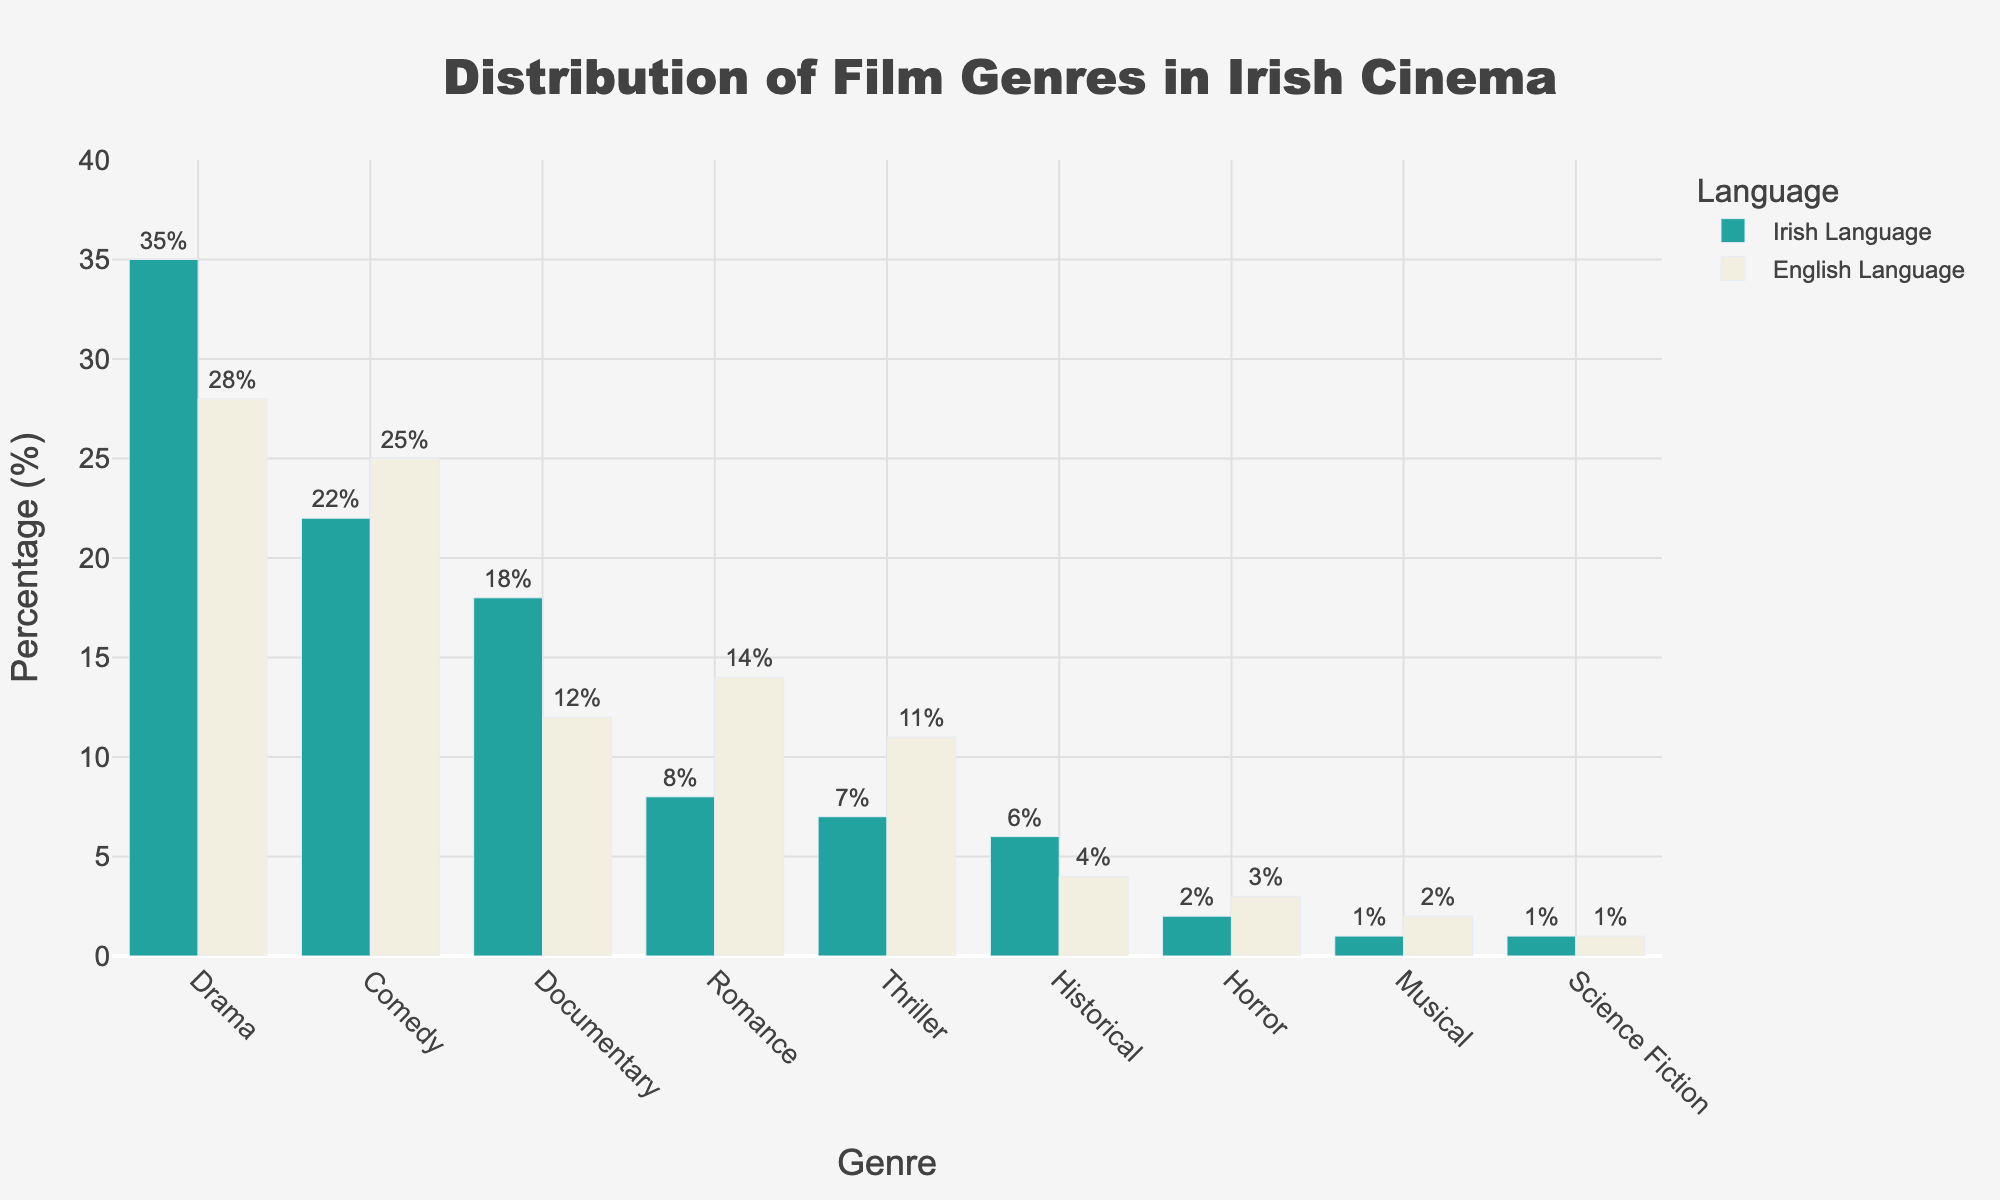Which genre has the highest percentage in Irish language films? According to the figure, the drama genre has the highest percentage in Irish language films, depicted by the tallest green bar.
Answer: Drama Which genre has a higher percentage in English language films compared to Irish language films? By comparing the heights of the bars for each genre, Romance and Thriller have a higher percentage in English language films compared to Irish language films.
Answer: Romance and Thriller What's the total percentage of Comedy and Documentary genres in Irish language films? The percentages for Comedy and Documentary genres in Irish language films are 22% and 18% respectively. Summing these values gives 22 + 18 = 40.
Answer: 40% Is there a genre that has the same percentage in both Irish and English language films? The Science Fiction genre has the same percentage in both Irish and English language films, depicted by the bars of equal height at 1%.
Answer: Science Fiction Which language has a higher percentage of Horror films? By comparing the heights of the bars representing Horror films, the bar for English language films is taller, indicating a higher percentage.
Answer: English Language What is the average percentage of genres in English language films? Adding the percentages of all genres in English language films (28 + 25 + 12 + 14 + 11 + 4 + 3 + 2 + 1) and then dividing by the number of genres (9) gives the average: (28 + 25 + 12 + 14 + 11 + 4 + 3 + 2 + 1) / 9 = 100/9 ≈ 11.1.
Answer: ~11.1% How many genres have less than 5% representation in Irish language films? By examining the heights of the bars, three genres have less than 5% representation in Irish language films—Horror, Musical, and Science Fiction.
Answer: Three Which genre has the smallest difference in percentages between Irish and English language films? Calculating the absolute differences for each genre: Drama (7), Comedy (3), Documentary (6), Romance (6), Thriller (4), Historical (2), Horror (1), Musical (1), Science Fiction (0) shows that Science Fiction has the smallest difference of 0.
Answer: Science Fiction What is the combined percentage of Historical genre in both languages? The percentages for the Historical genre are 6% for Irish language films and 4% for English language films. Summing them gives 6 + 4 = 10.
Answer: 10% In which language do Musical films have a higher representation? The bar for Musical films in English language is slightly taller than the one for Irish language, indicating higher representation in English language films.
Answer: English Language 